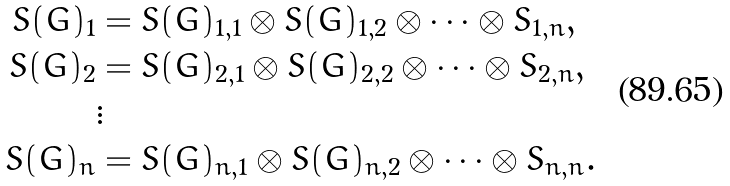Convert formula to latex. <formula><loc_0><loc_0><loc_500><loc_500>S ( G ) _ { 1 } & = S ( G ) _ { 1 , 1 } \otimes S ( G ) _ { 1 , 2 } \otimes \cdots \otimes S _ { 1 , n } , \\ S ( G ) _ { 2 } & = S ( G ) _ { 2 , 1 } \otimes S ( G ) _ { 2 , 2 } \otimes \cdots \otimes S _ { 2 , n } , \\ & \vdots \\ S ( G ) _ { n } & = S ( G ) _ { n , 1 } \otimes S ( G ) _ { n , 2 } \otimes \cdots \otimes S _ { n , n } .</formula> 